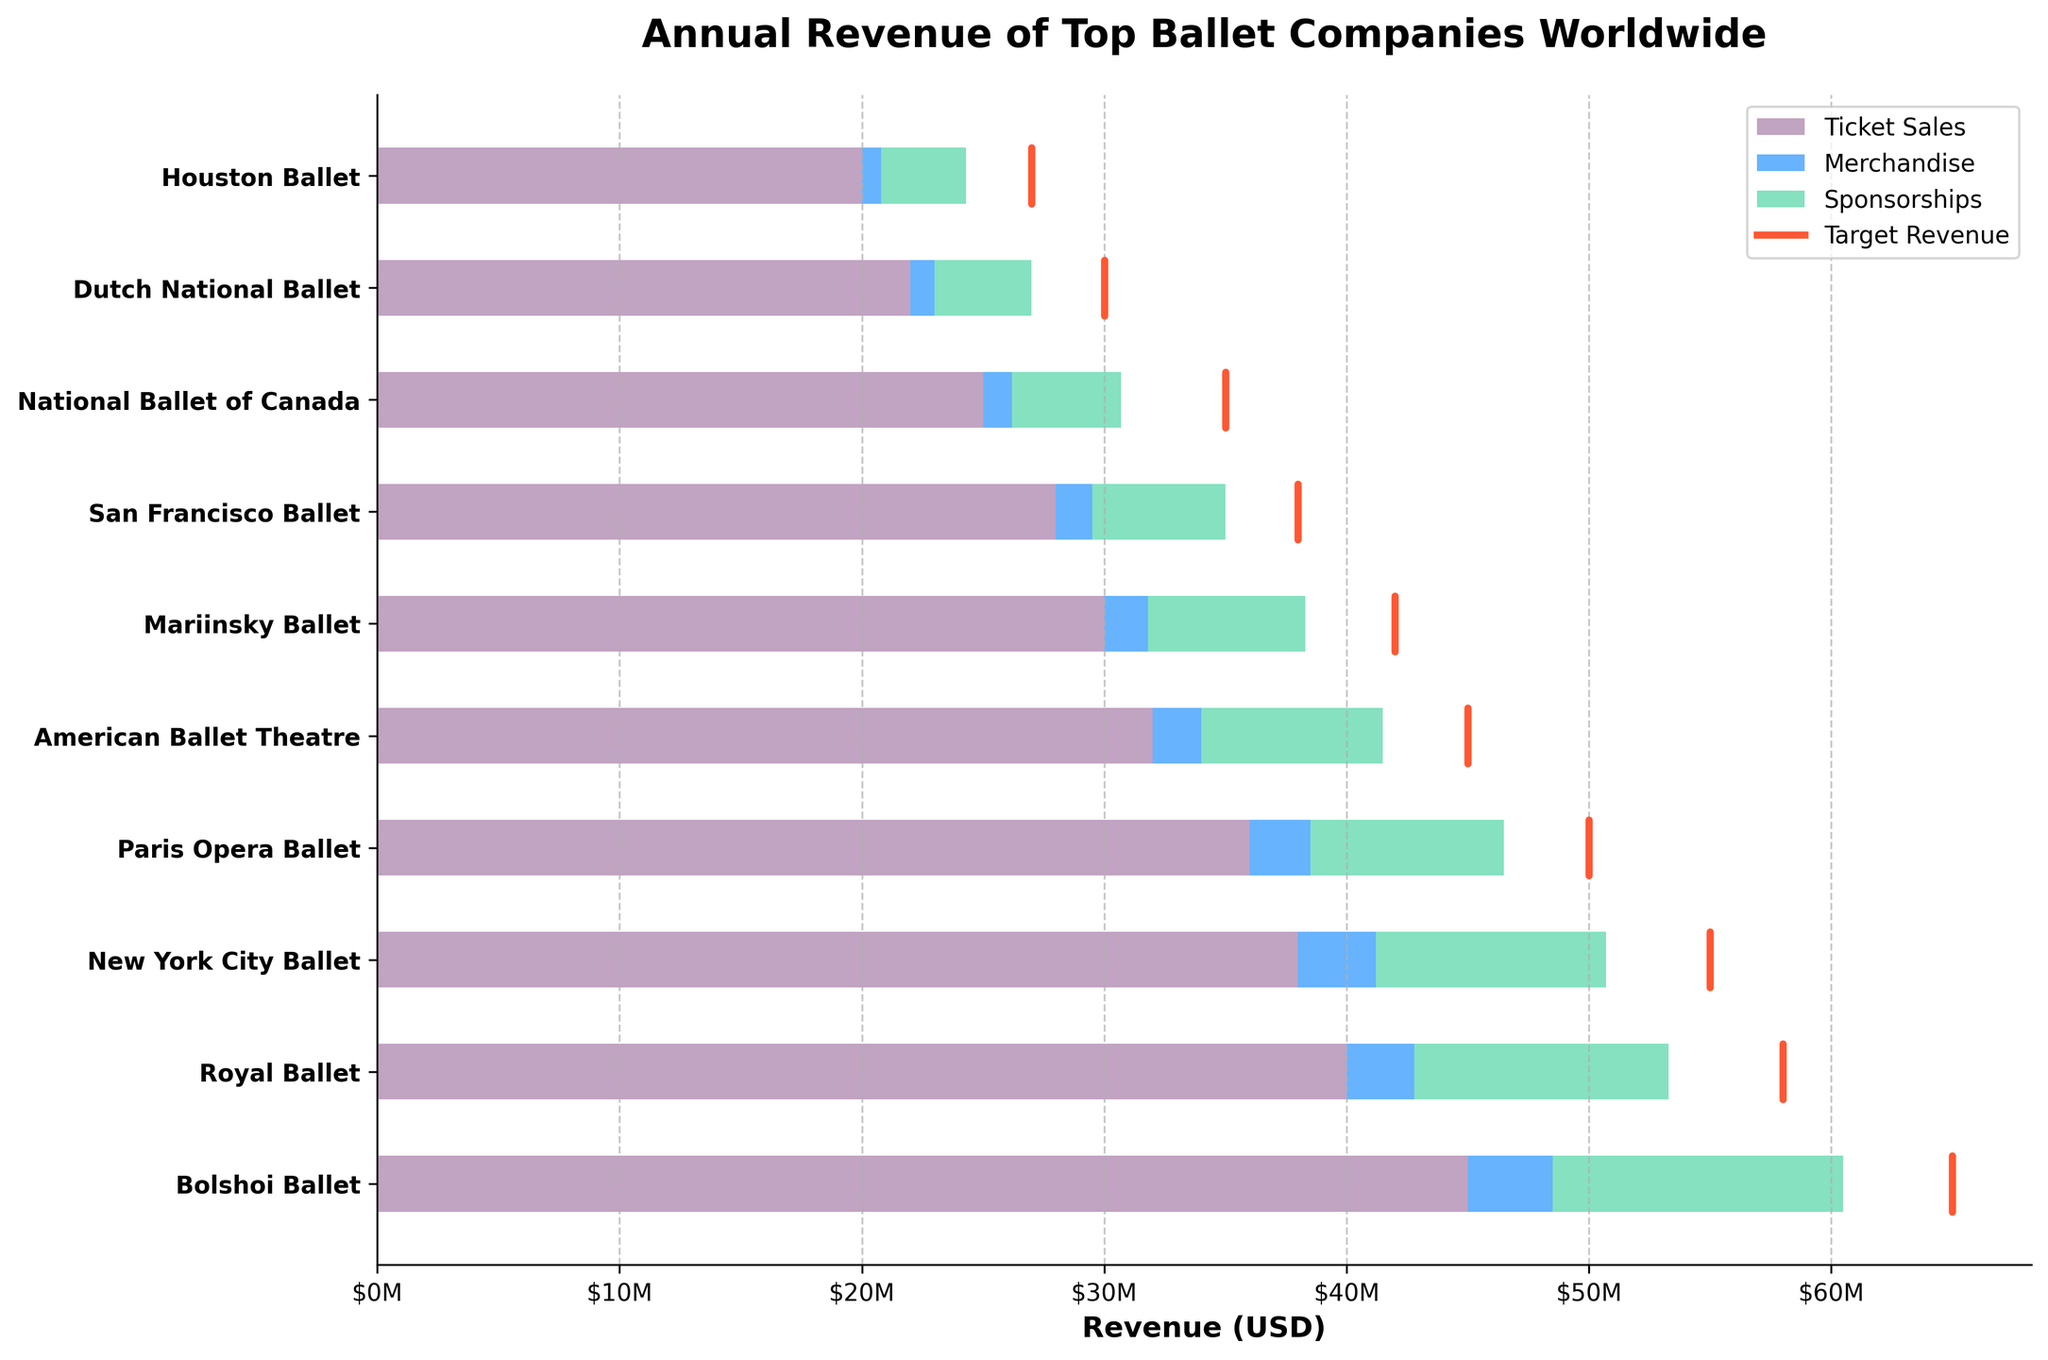What's the title of the figure? The title is located at the top of the figure, displaying the overall topic of the data presented. In this case, it reads "Annual Revenue of Top Ballet Companies Worldwide."
Answer: Annual Revenue of Top Ballet Companies Worldwide How many companies are included in the chart? Count the number of distinct companies listed along the y-axis of the chart.
Answer: 10 Which company has the highest ticket sales? Look at the width of the first bar segment for each company and find the one with the longest segment. Bolshoi Ballet has the longest red-colored bar segment, indicating the highest ticket sales.
Answer: Bolshoi Ballet What's the sum of revenue from merchandise for the Royal Ballet and New York City Ballet? Identify the length of the blue-colored segments for both the Royal Ballet and New York City Ballet. The Royal Ballet has $2.8M and New York City Ballet has $3.2M. The sum is $2.8M + $3.2M = $6.0M.
Answer: $6.0M Did the Paris Opera Ballet meet its target revenue? Compare the total length of the stacked bars (for ticket sales, merchandise, and sponsorships) with the target marker line. The Paris Opera Ballet's total revenue is less than its target line, indicating it did not meet its target.
Answer: No Which company has the smallest revenue from sponsorships? Look at the green-colored segment for each company and find the shortest one. The Houston Ballet has the shortest green-colored segment, indicating the smallest revenue from sponsorships.
Answer: Houston Ballet What's the total revenue for the San Francisco Ballet, and how does it compare to its target revenue? Add the values for ticket sales ($28M), merchandise ($1.5M), and sponsorships ($5.5M), resulting in total revenue of $35M. Compare this to the target revenue, which is $38M.
Answer: $35M, less than target Which company is closest to meeting its target revenue without exceeding it? Compare the total revenue of each company to its target and find the closest one below the target. The New York City Ballet's total revenue ($50.5M) is just under its target ($55M).
Answer: New York City Ballet What's the average target revenue for all the companies? Sum all the target revenue amounts ($65M + $58M + $55M + $50M + $45M + $42M + $38M + $35M + $30M + $27M) which equals $415M. Divide by the number of companies (10).
Answer: $41.5M 